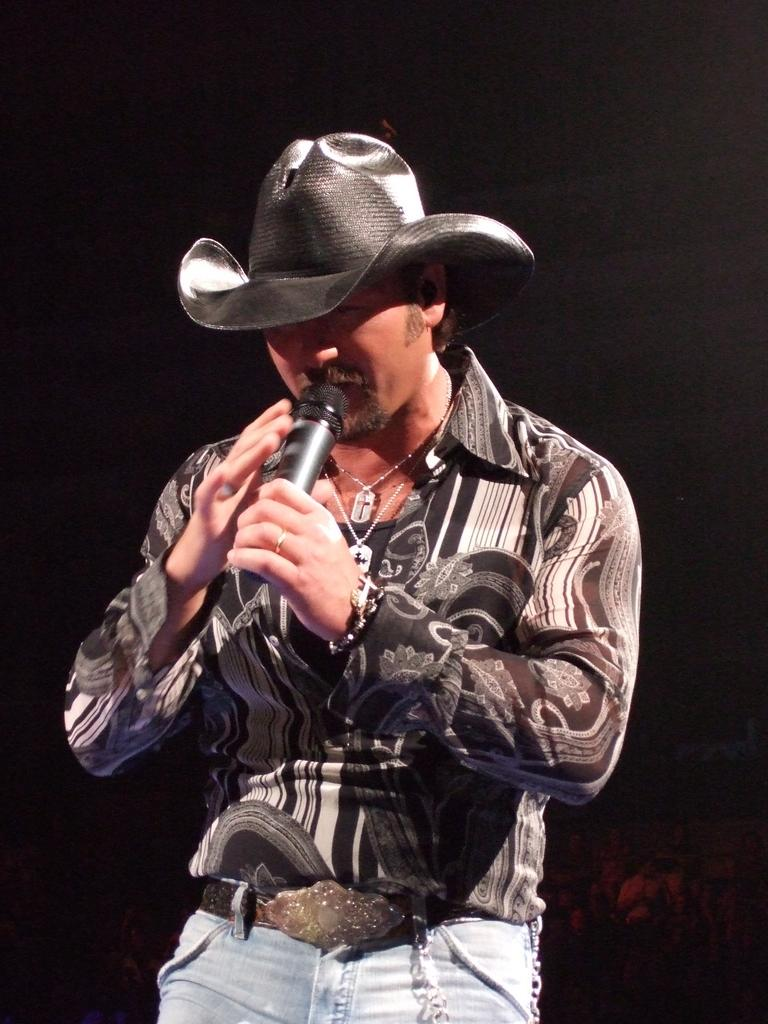What is the main subject of the image? There is a man in the image. What is the man doing in the image? The man is standing in the image. What object is the man holding in his hands? The man is holding a microphone in his hands. What type of doctor is the man pretending to be in the image? There is no indication in the image that the man is pretending to be a doctor, as he is holding a microphone and not any medical equipment. 